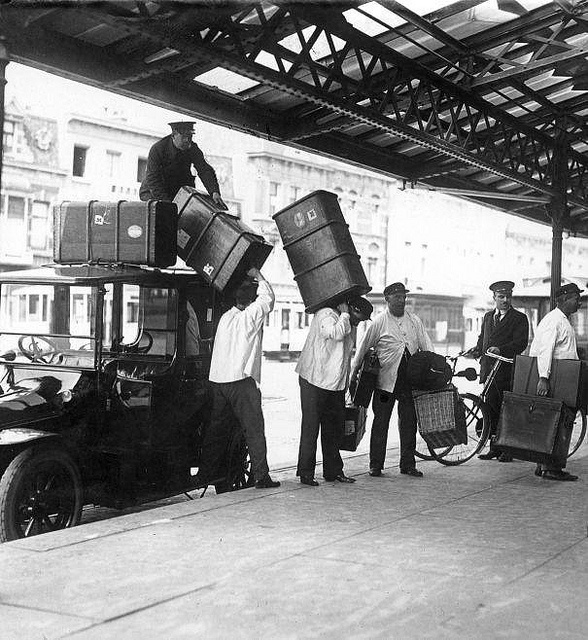Describe the objects in this image and their specific colors. I can see truck in black, white, gray, and darkgray tones, people in black, lightgray, gray, and darkgray tones, people in black, lightgray, darkgray, and gray tones, suitcase in black, dimgray, gray, and lightgray tones, and people in black, darkgray, gray, and lightgray tones in this image. 